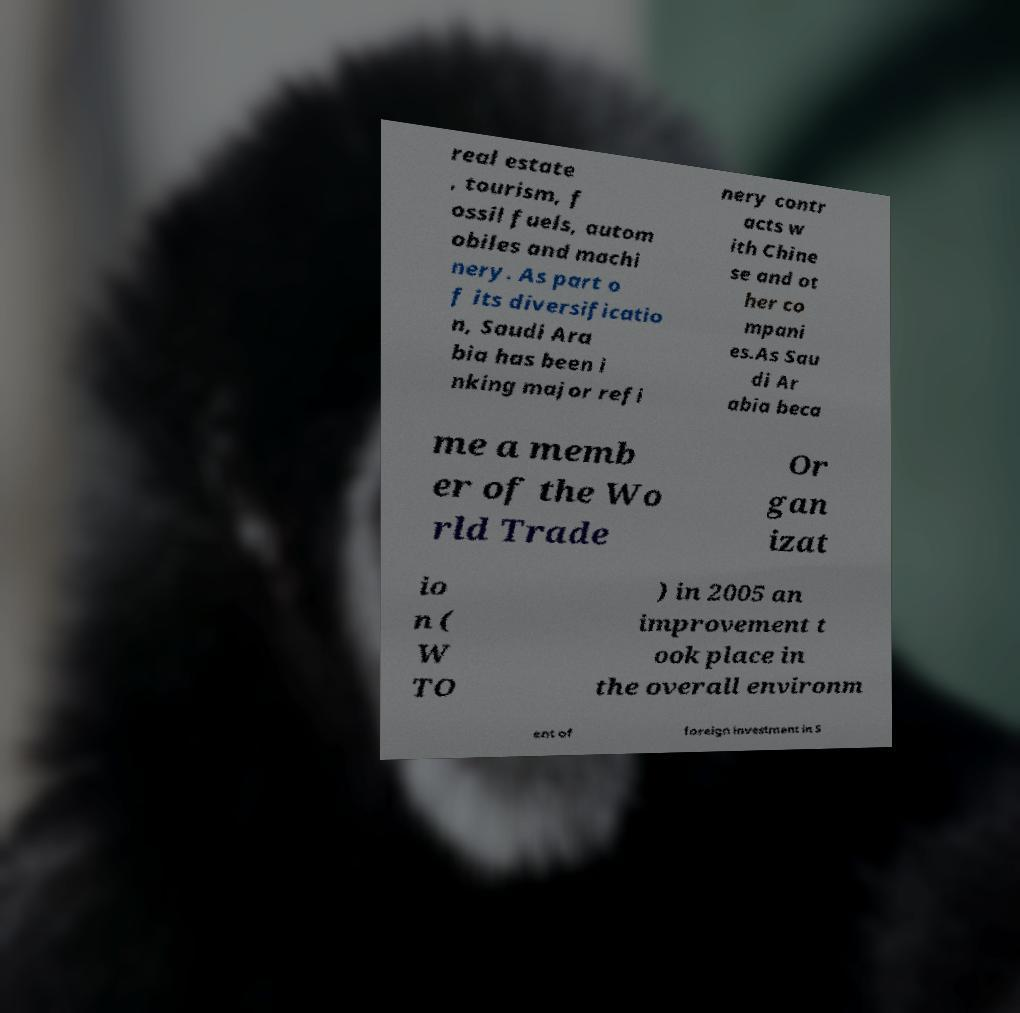Could you assist in decoding the text presented in this image and type it out clearly? real estate , tourism, f ossil fuels, autom obiles and machi nery. As part o f its diversificatio n, Saudi Ara bia has been i nking major refi nery contr acts w ith Chine se and ot her co mpani es.As Sau di Ar abia beca me a memb er of the Wo rld Trade Or gan izat io n ( W TO ) in 2005 an improvement t ook place in the overall environm ent of foreign investment in S 